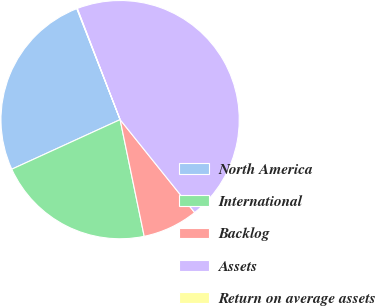Convert chart. <chart><loc_0><loc_0><loc_500><loc_500><pie_chart><fcel>North America<fcel>International<fcel>Backlog<fcel>Assets<fcel>Return on average assets<nl><fcel>25.91%<fcel>21.41%<fcel>7.52%<fcel>45.09%<fcel>0.07%<nl></chart> 